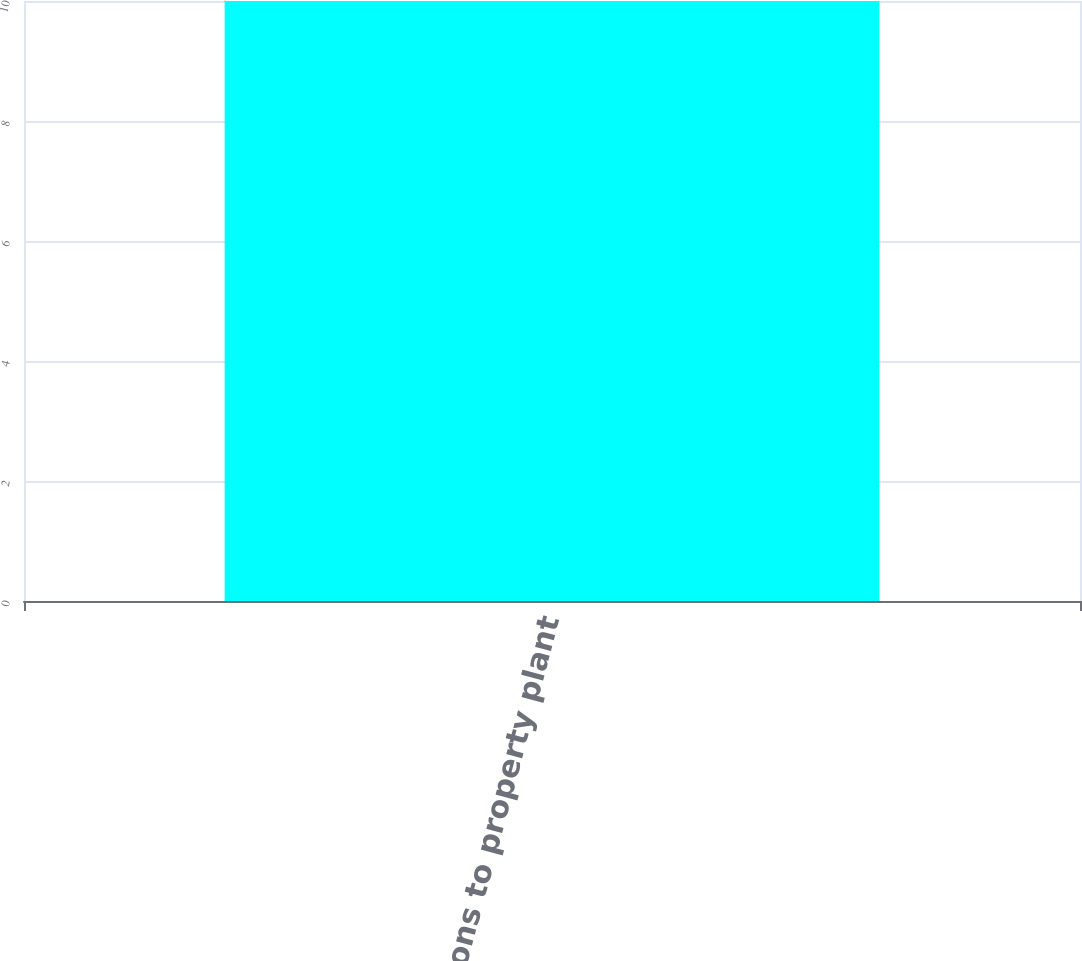Convert chart. <chart><loc_0><loc_0><loc_500><loc_500><bar_chart><fcel>Additions to property plant<nl><fcel>10<nl></chart> 